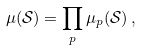<formula> <loc_0><loc_0><loc_500><loc_500>\mu ( \mathcal { S } ) = \prod _ { p } \mu _ { p } ( \mathcal { S } ) \, ,</formula> 